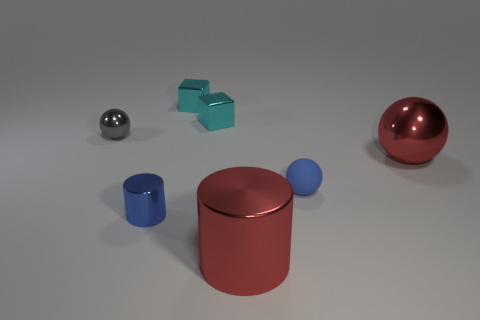Add 1 blue objects. How many objects exist? 8 Subtract all cylinders. How many objects are left? 5 Subtract 0 brown cylinders. How many objects are left? 7 Subtract all red cylinders. Subtract all tiny cyan matte cylinders. How many objects are left? 6 Add 6 red metallic spheres. How many red metallic spheres are left? 7 Add 4 small rubber balls. How many small rubber balls exist? 5 